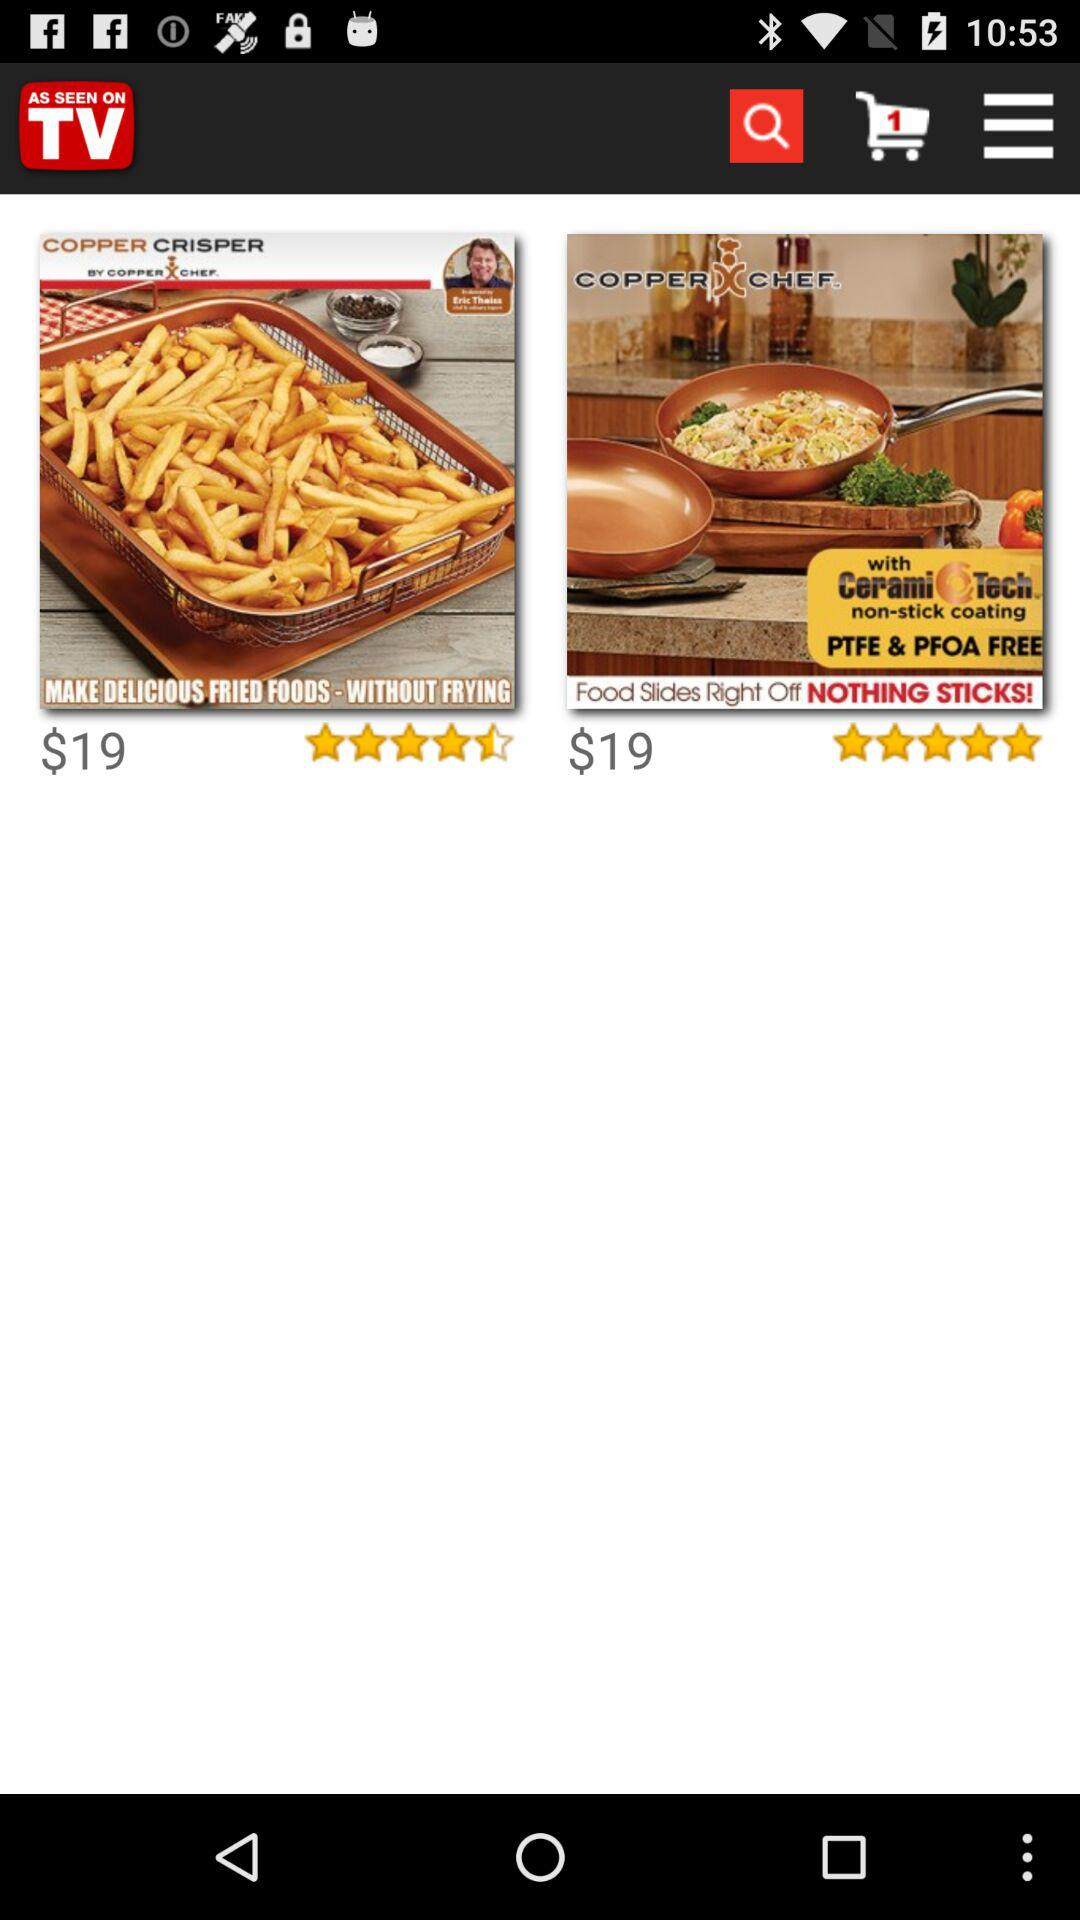What is the lowest rating? The lowest rating is 4.5 stars. 